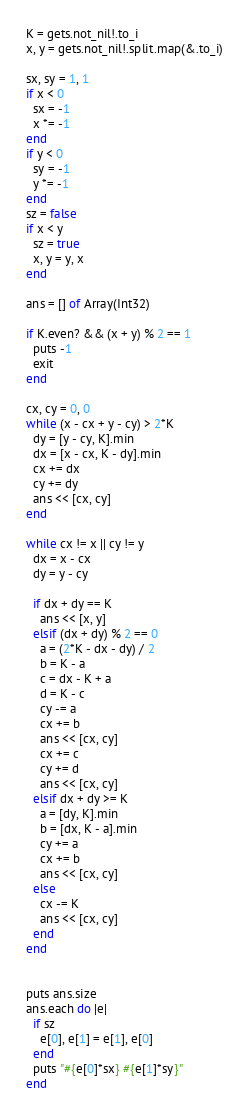Convert code to text. <code><loc_0><loc_0><loc_500><loc_500><_Crystal_>K = gets.not_nil!.to_i
x, y = gets.not_nil!.split.map(&.to_i)

sx, sy = 1, 1
if x < 0 
  sx = -1
  x *= -1
end
if y < 0
  sy = -1
  y *= -1
end
sz = false
if x < y
  sz = true
  x, y = y, x
end

ans = [] of Array(Int32)

if K.even? && (x + y) % 2 == 1
  puts -1
  exit
end

cx, cy = 0, 0
while (x - cx + y - cy) > 2*K
  dy = [y - cy, K].min
  dx = [x - cx, K - dy].min
  cx += dx
  cy += dy
  ans << [cx, cy]
end

while cx != x || cy != y
  dx = x - cx
  dy = y - cy

  if dx + dy == K
    ans << [x, y]
  elsif (dx + dy) % 2 == 0
    a = (2*K - dx - dy) / 2
    b = K - a
    c = dx - K + a
    d = K - c
    cy -= a
    cx += b
    ans << [cx, cy]
    cx += c
    cy += d
    ans << [cx, cy]
  elsif dx + dy >= K
    a = [dy, K].min
    b = [dx, K - a].min
    cy += a
    cx += b
    ans << [cx, cy]
  else
    cx -= K
    ans << [cx, cy]
  end
end


puts ans.size
ans.each do |e|
  if sz
    e[0], e[1] = e[1], e[0]
  end
  puts "#{e[0]*sx} #{e[1]*sy}"
end
</code> 